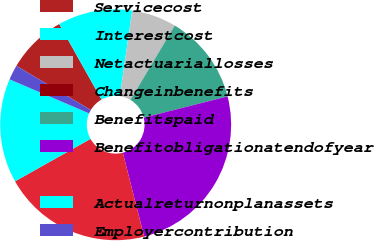Convert chart to OTSL. <chart><loc_0><loc_0><loc_500><loc_500><pie_chart><fcel>Servicecost<fcel>Interestcost<fcel>Netactuariallosses<fcel>Changeinbenefits<fcel>Benefitspaid<fcel>Benefitobligationatendofyear<fcel>Unnamed: 6<fcel>Actualreturnonplanassets<fcel>Employercontribution<nl><fcel>8.34%<fcel>10.42%<fcel>6.26%<fcel>0.01%<fcel>12.5%<fcel>24.98%<fcel>20.82%<fcel>14.58%<fcel>2.09%<nl></chart> 